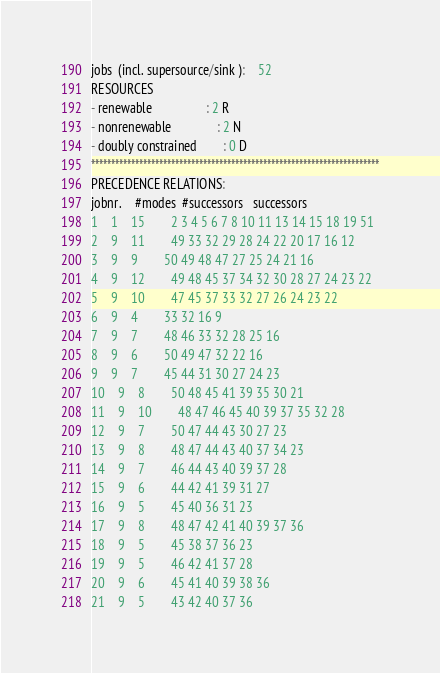Convert code to text. <code><loc_0><loc_0><loc_500><loc_500><_ObjectiveC_>jobs  (incl. supersource/sink ):	52
RESOURCES
- renewable                 : 2 R
- nonrenewable              : 2 N
- doubly constrained        : 0 D
************************************************************************
PRECEDENCE RELATIONS:
jobnr.    #modes  #successors   successors
1	1	15		2 3 4 5 6 7 8 10 11 13 14 15 18 19 51 
2	9	11		49 33 32 29 28 24 22 20 17 16 12 
3	9	9		50 49 48 47 27 25 24 21 16 
4	9	12		49 48 45 37 34 32 30 28 27 24 23 22 
5	9	10		47 45 37 33 32 27 26 24 23 22 
6	9	4		33 32 16 9 
7	9	7		48 46 33 32 28 25 16 
8	9	6		50 49 47 32 22 16 
9	9	7		45 44 31 30 27 24 23 
10	9	8		50 48 45 41 39 35 30 21 
11	9	10		48 47 46 45 40 39 37 35 32 28 
12	9	7		50 47 44 43 30 27 23 
13	9	8		48 47 44 43 40 37 34 23 
14	9	7		46 44 43 40 39 37 28 
15	9	6		44 42 41 39 31 27 
16	9	5		45 40 36 31 23 
17	9	8		48 47 42 41 40 39 37 36 
18	9	5		45 38 37 36 23 
19	9	5		46 42 41 37 28 
20	9	6		45 41 40 39 38 36 
21	9	5		43 42 40 37 36 </code> 